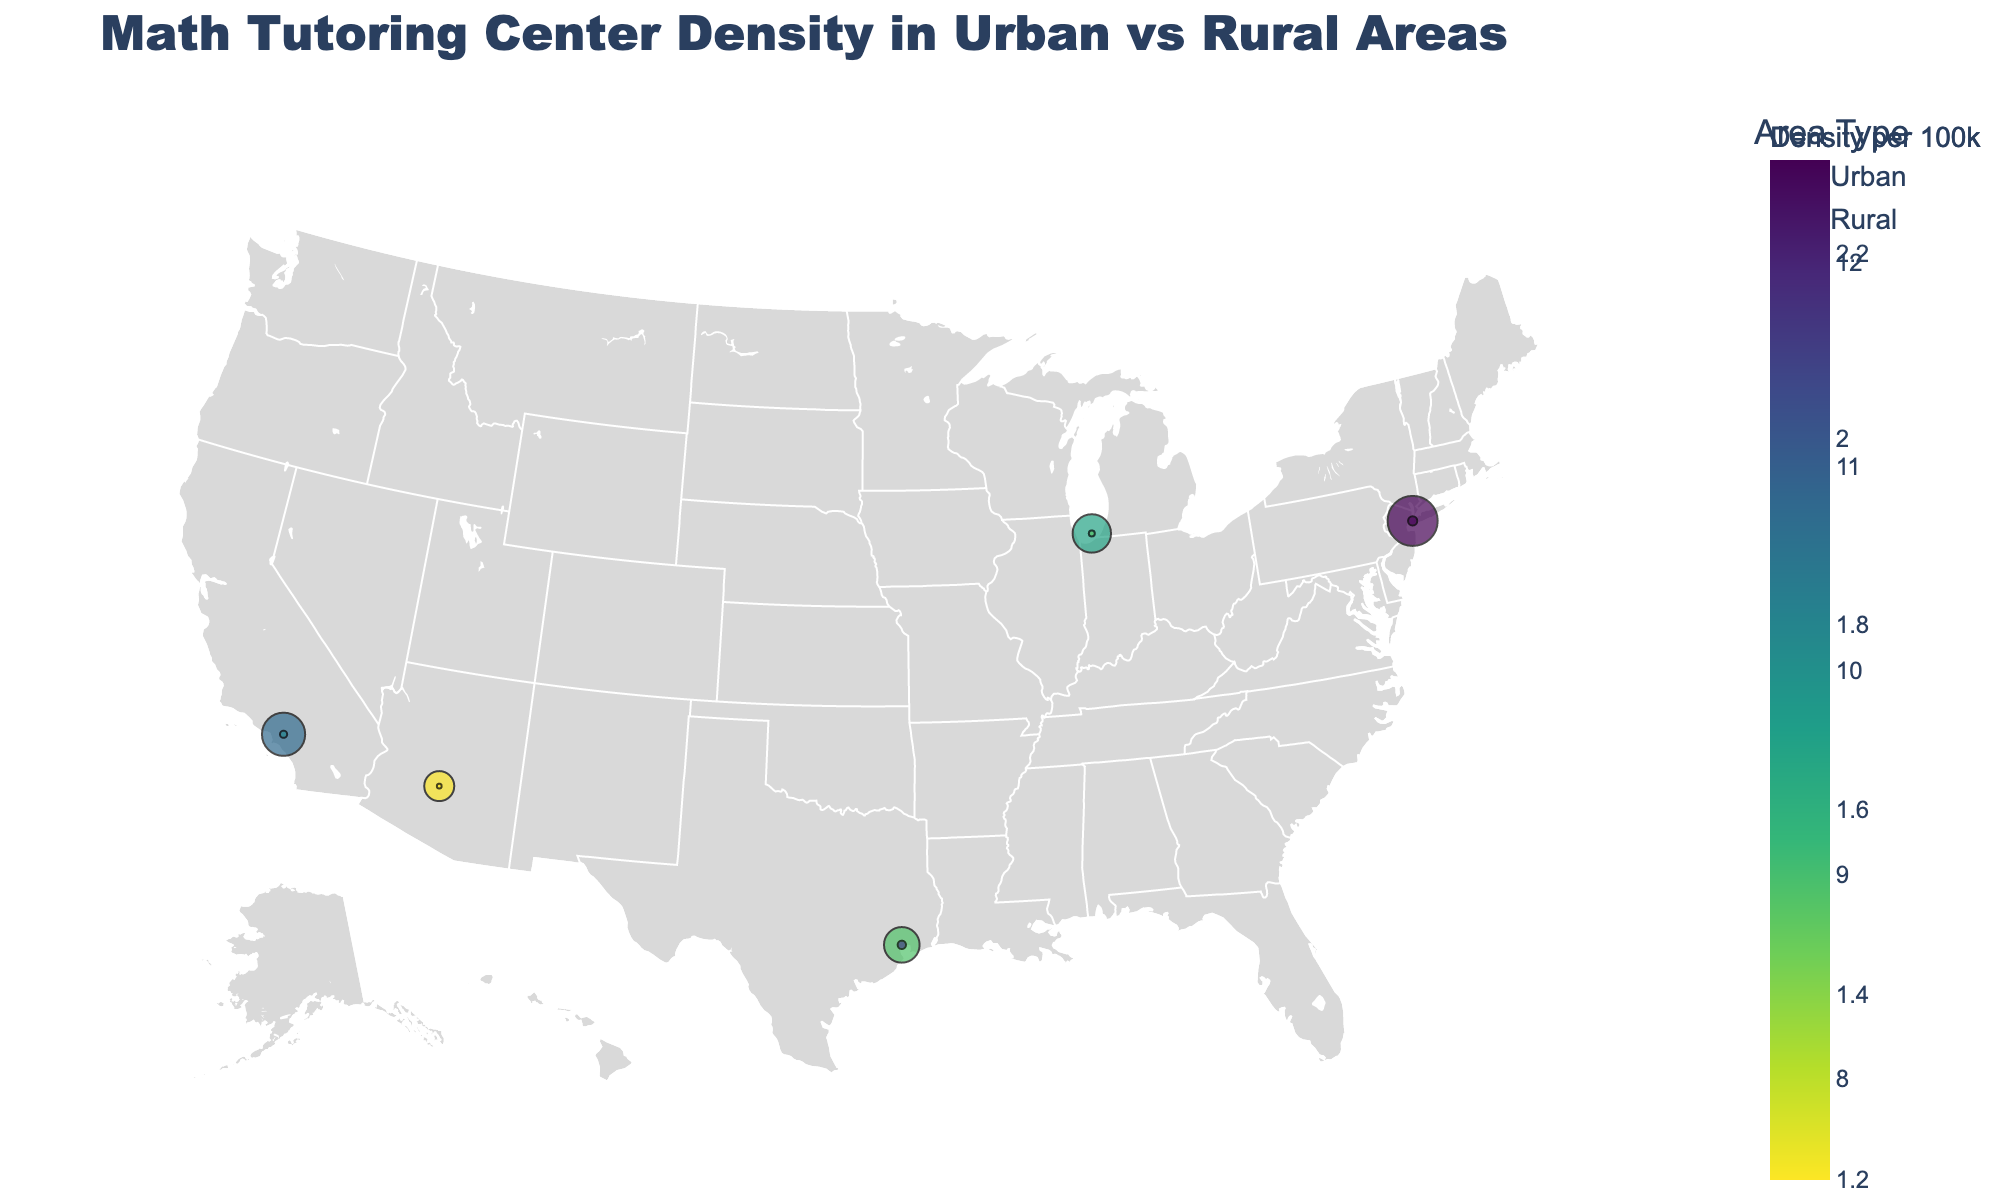what is the title of the plot? The title of the plot is typically located at the top center of the figure and visually stands out due to its font size and style. Here, the title is "Math Tutoring Center Density in Urban vs Rural Areas" as seen at the top of the plot.
Answer: Math Tutoring Center Density in Urban vs Rural Areas which region has the highest density of math tutoring centers? To determine this, examine the markers and their sizes on the plot. The largest marker usually denotes the highest density. Here, New York City has the largest marker, corresponding to the highest density of 12.5 per 100k population.
Answer: New York City what is the smallest density value, and which region does it belong to? The smallest marker on the plot represents the region with the lowest density. This marker is in Rural Alaska, which has the smallest density value of 1.2 per 100k population.
Answer: 1.2, Rural Alaska compare the average student age in urban areas versus rural areas. To compare the average student age, calculate the mean ages for both urban and rural areas by averaging their values. For urban areas: (15.3 + 14.7 + 16.1 + 15.8 + 14.9) / 5 = 15.36. For rural areas: (13.5 + 12.9 + 14.2 + 13.8 + 13.1) / 5 = 13.5. Therefore, urban areas have a higher average student age.
Answer: Urban: 15.36, Rural: 13.5 how many regions are represented in this plot? Count the number of distinct regions labeled on the plot, which correspond to the markers. There are ten markers, each signifying a different region.
Answer: 10 what is the density difference between Chicago and Rural Mississippi? Subtract the density value of Rural Mississippi from that of Chicago. The density of Chicago is 9.6, and that of Rural Mississippi is 1.5. Thus, the difference is 9.6 - 1.5 = 8.1.
Answer: 8.1 which urban region has the lowest density of math tutoring centers, and what is its density? Identify the urban region with the smallest marker among the urban areas. Phoenix has the smallest marker among urban regions, with a density of 7.5 per 100k population.
Answer: Phoenix, 7.5 what geographical pattern can you observe in the distribution of math tutoring centers? Examining the plot, urban areas tend to have higher densities of math tutoring centers compared to rural areas, evident from the larger markers clustered around cities like NYC, Los Angeles, and Chicago, while smaller markers are scattered in rural regions.
Answer: Urban areas have higher densities what is the average density of math tutoring centers in rural regions? Calculate the average density by summing up the densities of rural regions and dividing by the number of rural regions. (2.3 + 1.8 + 1.5 + 2.1 + 1.2) / 5 = 1.78 per 100k population.
Answer: 1.78 